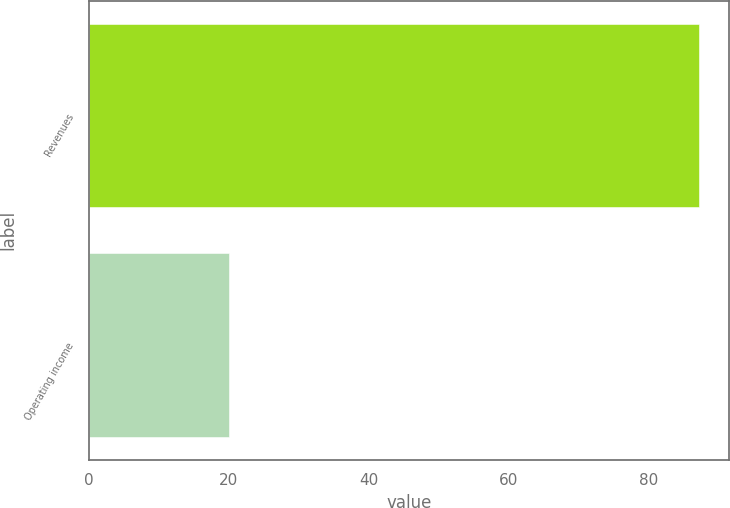Convert chart to OTSL. <chart><loc_0><loc_0><loc_500><loc_500><bar_chart><fcel>Revenues<fcel>Operating income<nl><fcel>87.2<fcel>20<nl></chart> 